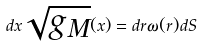Convert formula to latex. <formula><loc_0><loc_0><loc_500><loc_500>d { x } \sqrt { g _ { M } } ( { x } ) = d r \omega ( r ) d S</formula> 